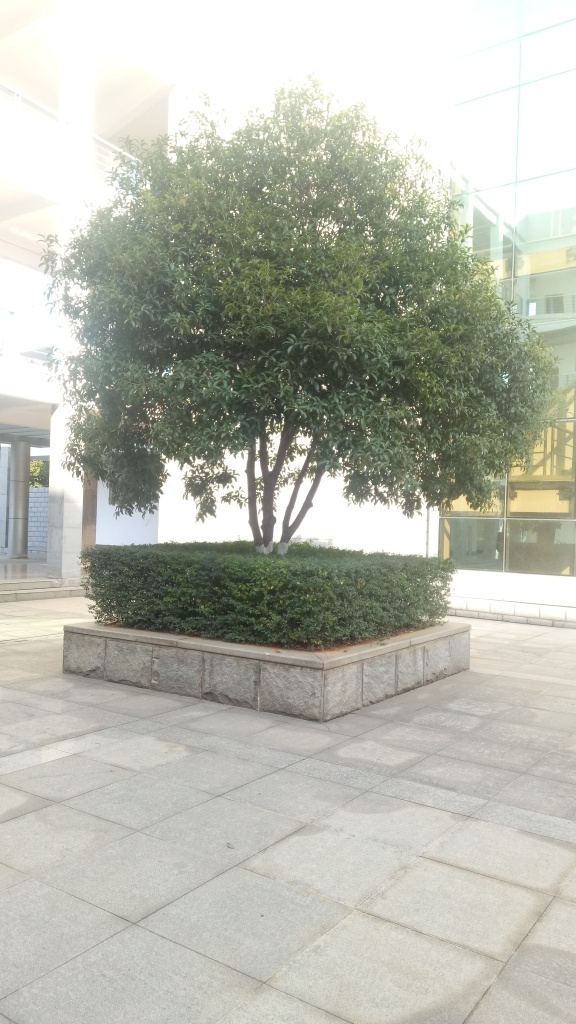Is there an environmental significance to the presence of the tree in this setting? Yes, trees in urban settings are crucial for enhancing air quality, providing shade, and offering aesthetic value to the otherwise concrete landscape. This tree in particular seems to also add a natural element to the space, which can positively impact the well-being of people who pass by or spend time here. 